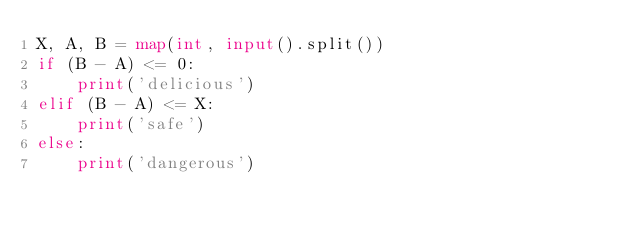Convert code to text. <code><loc_0><loc_0><loc_500><loc_500><_Python_>X, A, B = map(int, input().split())
if (B - A) <= 0:
	print('delicious')
elif (B - A) <= X:
	print('safe')
else:
	print('dangerous')</code> 